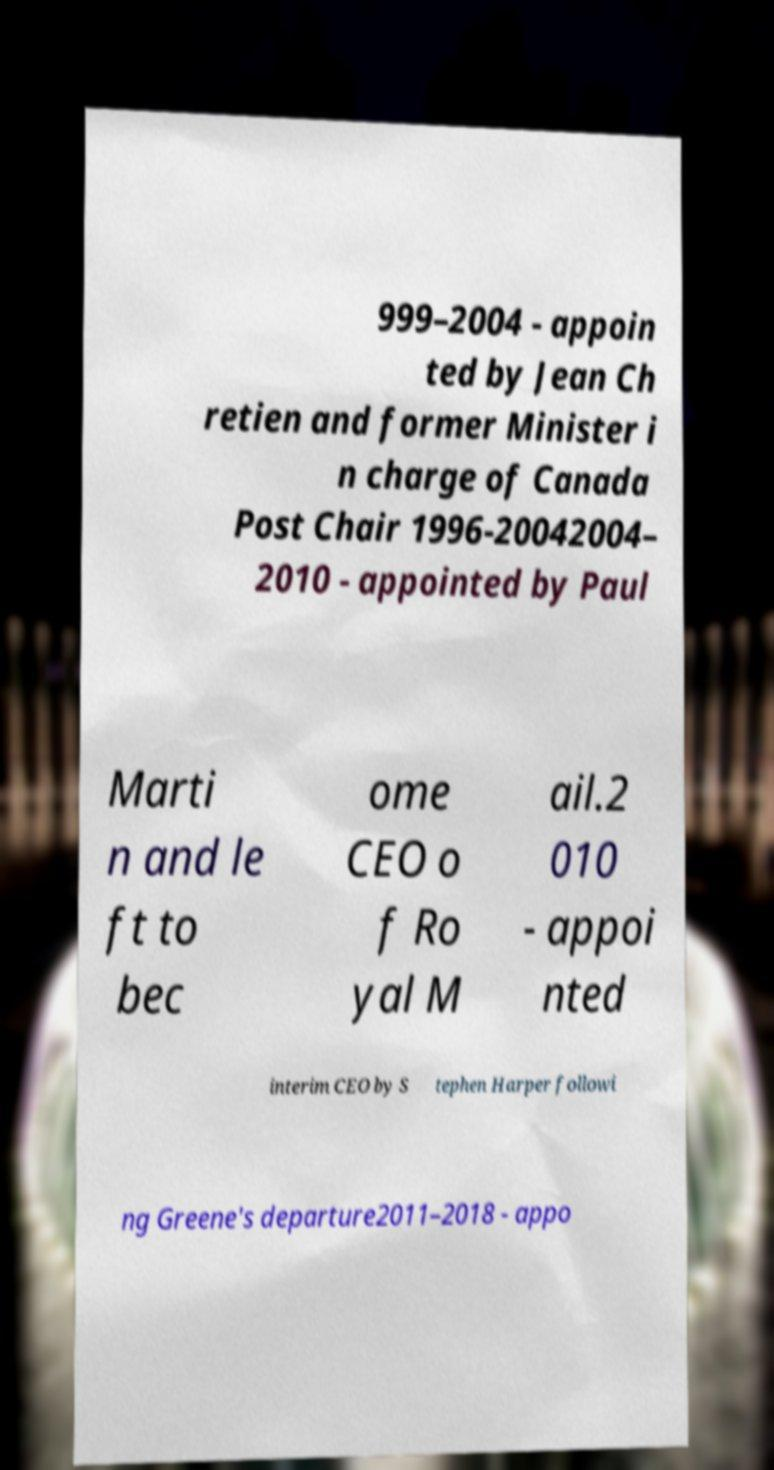There's text embedded in this image that I need extracted. Can you transcribe it verbatim? 999–2004 - appoin ted by Jean Ch retien and former Minister i n charge of Canada Post Chair 1996-20042004– 2010 - appointed by Paul Marti n and le ft to bec ome CEO o f Ro yal M ail.2 010 - appoi nted interim CEO by S tephen Harper followi ng Greene's departure2011–2018 - appo 